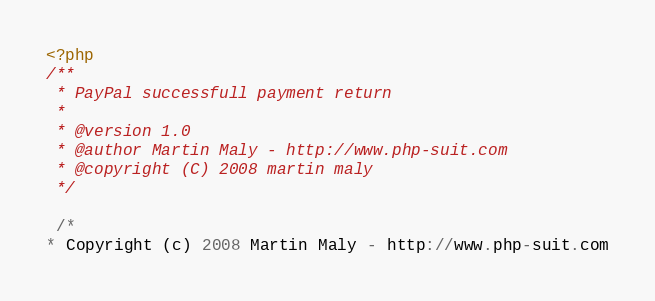<code> <loc_0><loc_0><loc_500><loc_500><_PHP_><?php
/**
 * PayPal successfull payment return
 *
 * @version 1.0
 * @author Martin Maly - http://www.php-suit.com
 * @copyright (C) 2008 martin maly
 */
 
 /*
* Copyright (c) 2008 Martin Maly - http://www.php-suit.com</code> 